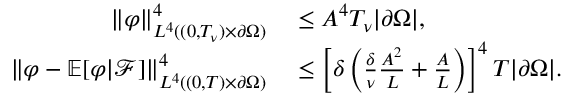Convert formula to latex. <formula><loc_0><loc_0><loc_500><loc_500>\begin{array} { r l } { \left \| \varphi \right \| _ { L ^ { 4 } ( ( 0 , T _ { \nu } ) \times \partial \Omega ) } ^ { 4 } } & \leq A ^ { 4 } T _ { \nu } | \partial \Omega | , } \\ { \left \| \varphi - \mathbb { E } [ \varphi | \mathcal { F } ] \right \| _ { L ^ { 4 } ( ( 0 , T ) \times \partial \Omega ) } ^ { 4 } } & \leq \left [ \delta \left ( \frac { \delta } { \nu } \frac { A ^ { 2 } } L + \frac { A } { L } \right ) \right ] ^ { 4 } T | \partial \Omega | . } \end{array}</formula> 